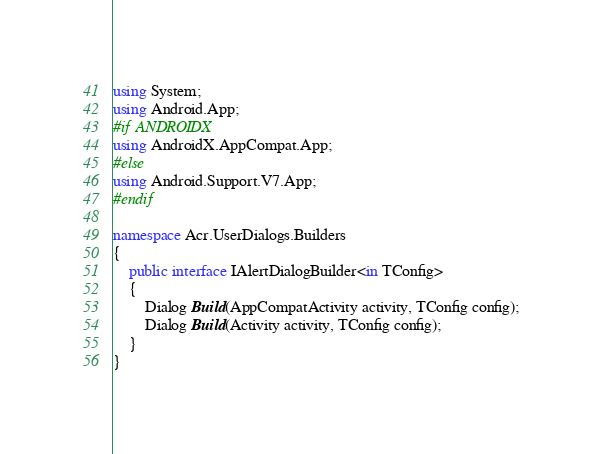<code> <loc_0><loc_0><loc_500><loc_500><_C#_>using System;
using Android.App;
#if ANDROIDX
using AndroidX.AppCompat.App;
#else
using Android.Support.V7.App;
#endif

namespace Acr.UserDialogs.Builders
{
    public interface IAlertDialogBuilder<in TConfig>
    {
        Dialog Build(AppCompatActivity activity, TConfig config);
        Dialog Build(Activity activity, TConfig config);
    }
}</code> 